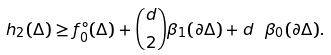<formula> <loc_0><loc_0><loc_500><loc_500>h _ { 2 } ( \Delta ) \geq f _ { 0 } ^ { \circ } ( \Delta ) + { d \choose 2 } \beta _ { 1 } ( \partial \Delta ) + d \ \beta _ { 0 } ( \partial \Delta ) .</formula> 